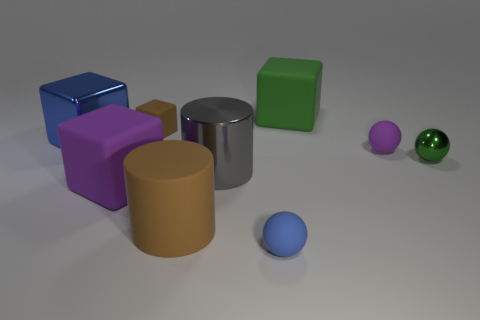Subtract all blue spheres. Subtract all blue cubes. How many spheres are left? 2 Subtract all spheres. How many objects are left? 6 Subtract 0 purple cylinders. How many objects are left? 9 Subtract all small yellow shiny spheres. Subtract all blue rubber spheres. How many objects are left? 8 Add 2 tiny purple balls. How many tiny purple balls are left? 3 Add 2 small gray metal cubes. How many small gray metal cubes exist? 2 